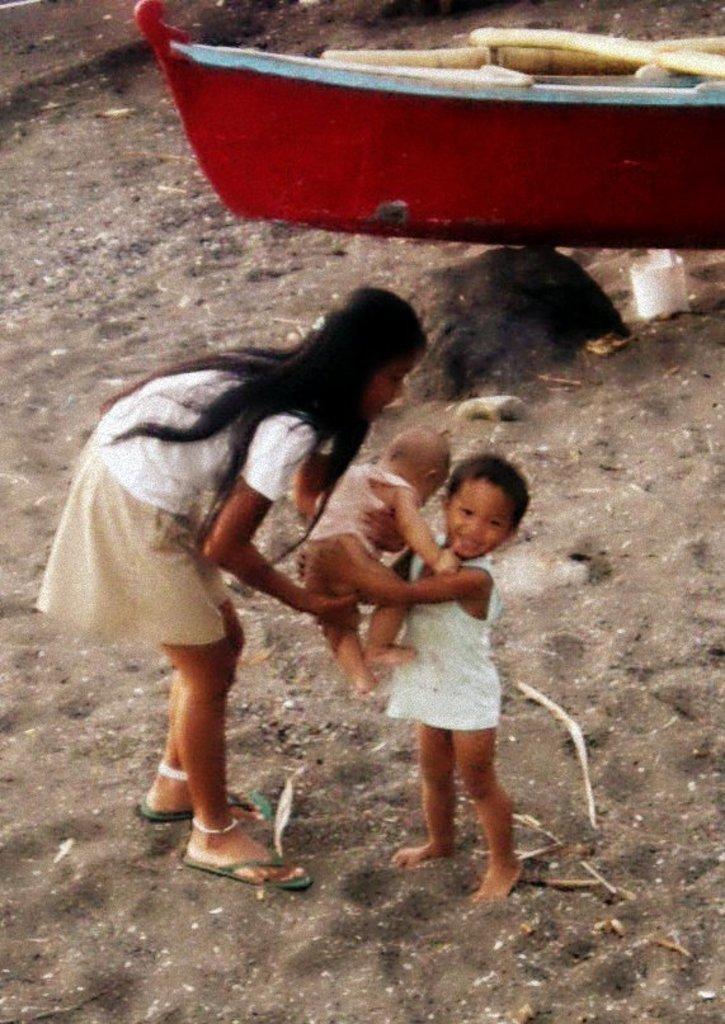Can you describe this image briefly? In the center of the image we can see a boy standing and holding a baby in his hand, next to him there is a girl. In the background we can see a boat. At the bottom there is sand. 